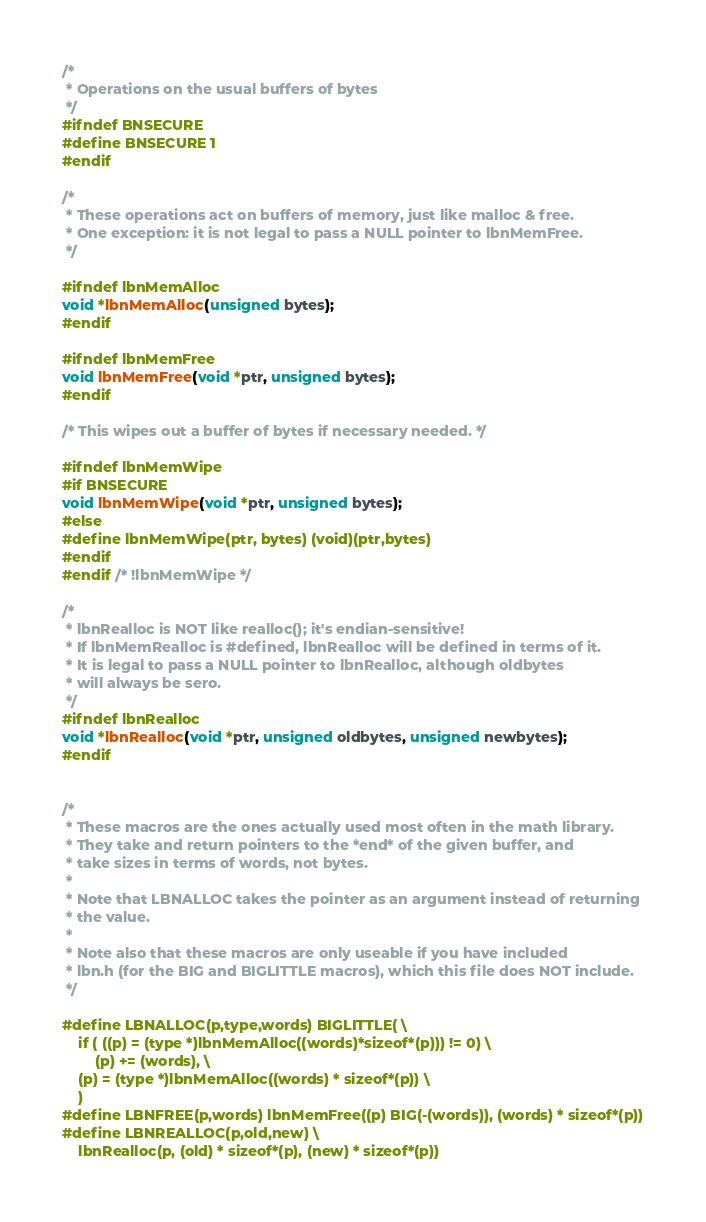<code> <loc_0><loc_0><loc_500><loc_500><_C_>/*
 * Operations on the usual buffers of bytes
 */
#ifndef BNSECURE
#define BNSECURE 1
#endif

/*
 * These operations act on buffers of memory, just like malloc & free.
 * One exception: it is not legal to pass a NULL pointer to lbnMemFree.
 */

#ifndef lbnMemAlloc
void *lbnMemAlloc(unsigned bytes);
#endif

#ifndef lbnMemFree
void lbnMemFree(void *ptr, unsigned bytes);
#endif

/* This wipes out a buffer of bytes if necessary needed. */

#ifndef lbnMemWipe
#if BNSECURE
void lbnMemWipe(void *ptr, unsigned bytes);
#else
#define lbnMemWipe(ptr, bytes) (void)(ptr,bytes)
#endif
#endif /* !lbnMemWipe */

/*
 * lbnRealloc is NOT like realloc(); it's endian-sensitive!
 * If lbnMemRealloc is #defined, lbnRealloc will be defined in terms of it.
 * It is legal to pass a NULL pointer to lbnRealloc, although oldbytes
 * will always be sero.
 */
#ifndef lbnRealloc
void *lbnRealloc(void *ptr, unsigned oldbytes, unsigned newbytes);
#endif


/*
 * These macros are the ones actually used most often in the math library.
 * They take and return pointers to the *end* of the given buffer, and
 * take sizes in terms of words, not bytes.
 *
 * Note that LBNALLOC takes the pointer as an argument instead of returning
 * the value.
 *
 * Note also that these macros are only useable if you have included
 * lbn.h (for the BIG and BIGLITTLE macros), which this file does NOT include.
 */

#define LBNALLOC(p,type,words) BIGLITTLE( \
	if ( ((p) = (type *)lbnMemAlloc((words)*sizeof*(p))) != 0) \
		(p) += (words), \
	(p) = (type *)lbnMemAlloc((words) * sizeof*(p)) \
	)
#define LBNFREE(p,words) lbnMemFree((p) BIG(-(words)), (words) * sizeof*(p))
#define LBNREALLOC(p,old,new) \
	lbnRealloc(p, (old) * sizeof*(p), (new) * sizeof*(p))</code> 